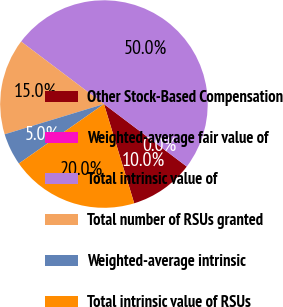Convert chart. <chart><loc_0><loc_0><loc_500><loc_500><pie_chart><fcel>Other Stock-Based Compensation<fcel>Weighted-average fair value of<fcel>Total intrinsic value of<fcel>Total number of RSUs granted<fcel>Weighted-average intrinsic<fcel>Total intrinsic value of RSUs<nl><fcel>10.0%<fcel>0.0%<fcel>50.0%<fcel>15.0%<fcel>5.0%<fcel>20.0%<nl></chart> 